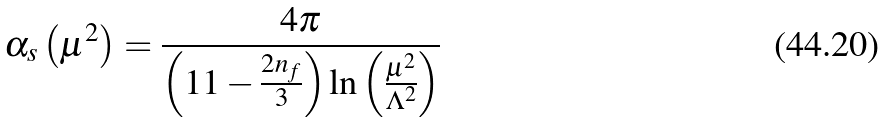<formula> <loc_0><loc_0><loc_500><loc_500>\alpha _ { s } \left ( \mu ^ { 2 } \right ) = \frac { 4 \pi } { \left ( 1 1 - \frac { 2 n _ { f } } { 3 } \right ) \ln \left ( \frac { \mu ^ { 2 } } { \Lambda ^ { 2 } } \right ) }</formula> 